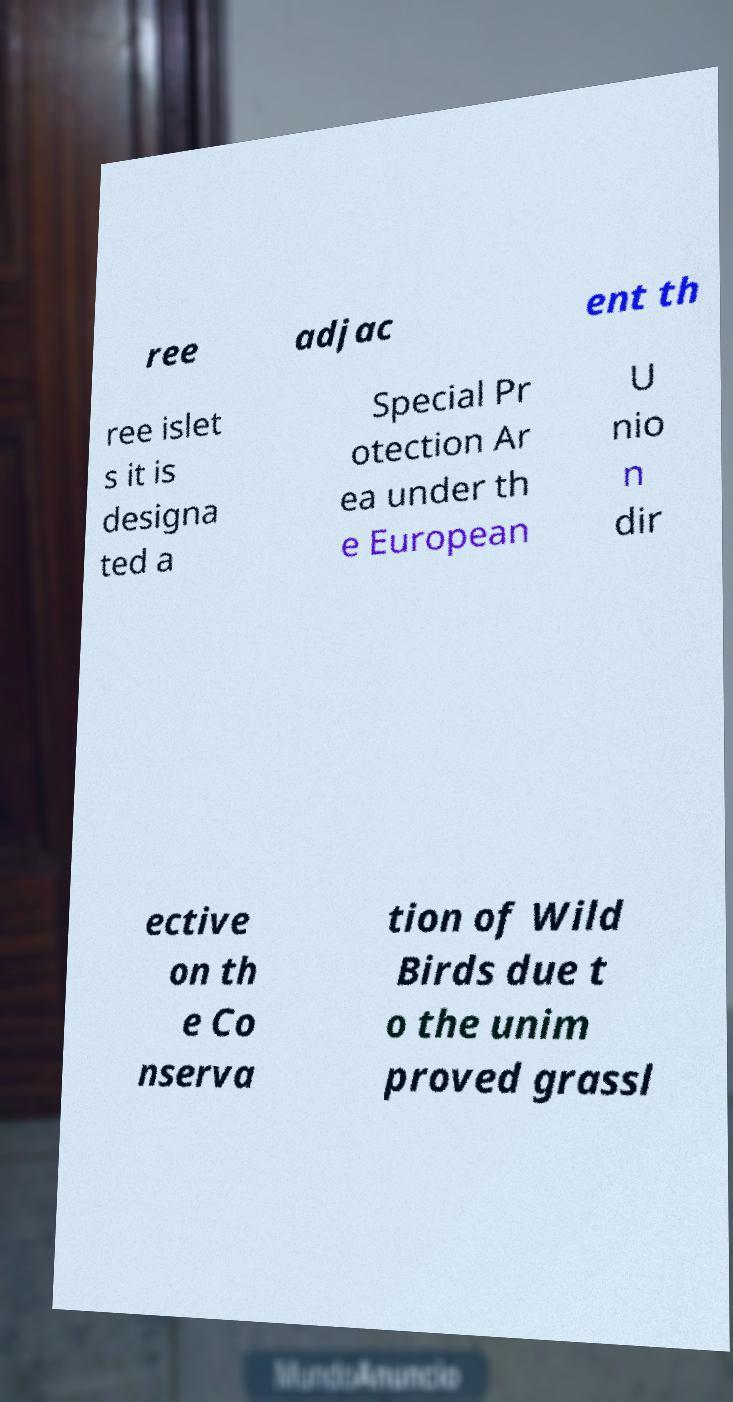What messages or text are displayed in this image? I need them in a readable, typed format. ree adjac ent th ree islet s it is designa ted a Special Pr otection Ar ea under th e European U nio n dir ective on th e Co nserva tion of Wild Birds due t o the unim proved grassl 